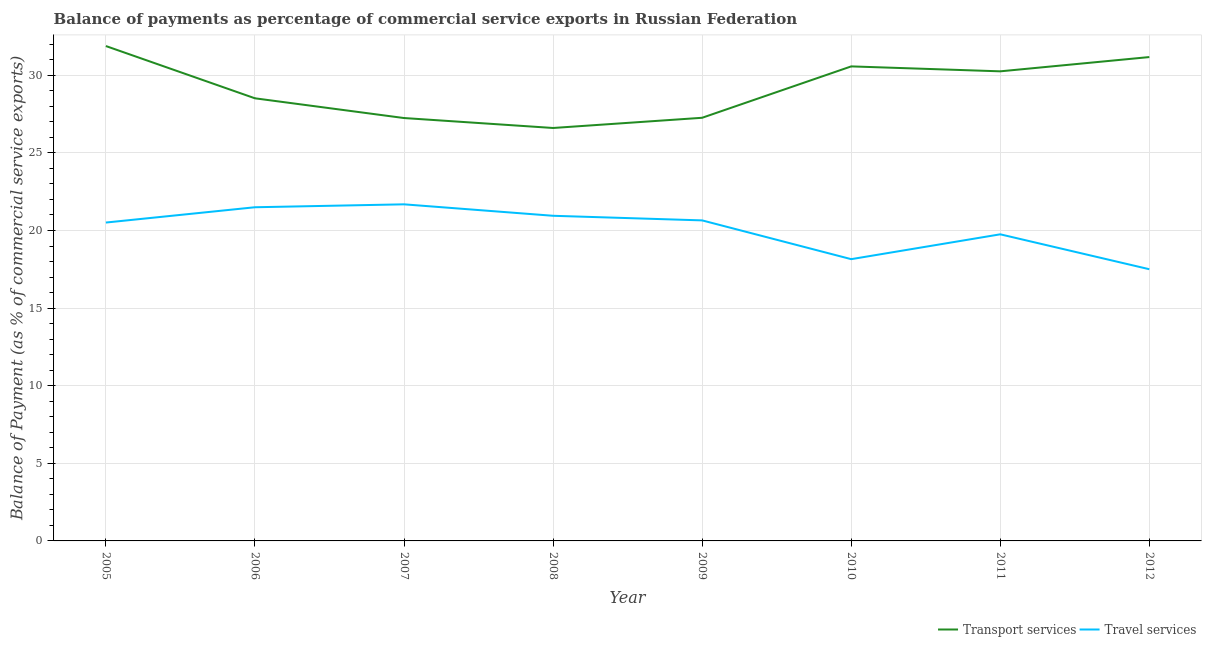Does the line corresponding to balance of payments of transport services intersect with the line corresponding to balance of payments of travel services?
Your response must be concise. No. Is the number of lines equal to the number of legend labels?
Your response must be concise. Yes. What is the balance of payments of transport services in 2012?
Provide a succinct answer. 31.17. Across all years, what is the maximum balance of payments of transport services?
Your answer should be compact. 31.88. Across all years, what is the minimum balance of payments of travel services?
Your response must be concise. 17.5. In which year was the balance of payments of transport services minimum?
Provide a short and direct response. 2008. What is the total balance of payments of travel services in the graph?
Ensure brevity in your answer.  160.7. What is the difference between the balance of payments of transport services in 2010 and that in 2012?
Your answer should be very brief. -0.6. What is the difference between the balance of payments of travel services in 2010 and the balance of payments of transport services in 2005?
Your answer should be very brief. -13.73. What is the average balance of payments of transport services per year?
Your answer should be compact. 29.19. In the year 2009, what is the difference between the balance of payments of transport services and balance of payments of travel services?
Provide a short and direct response. 6.61. What is the ratio of the balance of payments of transport services in 2009 to that in 2012?
Your answer should be compact. 0.87. Is the balance of payments of travel services in 2010 less than that in 2011?
Your response must be concise. Yes. Is the difference between the balance of payments of travel services in 2009 and 2011 greater than the difference between the balance of payments of transport services in 2009 and 2011?
Your answer should be very brief. Yes. What is the difference between the highest and the second highest balance of payments of travel services?
Offer a terse response. 0.19. What is the difference between the highest and the lowest balance of payments of travel services?
Your answer should be very brief. 4.18. In how many years, is the balance of payments of travel services greater than the average balance of payments of travel services taken over all years?
Offer a very short reply. 5. Is the balance of payments of transport services strictly less than the balance of payments of travel services over the years?
Make the answer very short. No. How many lines are there?
Keep it short and to the point. 2. How many years are there in the graph?
Offer a terse response. 8. Are the values on the major ticks of Y-axis written in scientific E-notation?
Give a very brief answer. No. Where does the legend appear in the graph?
Your answer should be very brief. Bottom right. What is the title of the graph?
Your answer should be compact. Balance of payments as percentage of commercial service exports in Russian Federation. Does "Savings" appear as one of the legend labels in the graph?
Your answer should be very brief. No. What is the label or title of the Y-axis?
Provide a short and direct response. Balance of Payment (as % of commercial service exports). What is the Balance of Payment (as % of commercial service exports) of Transport services in 2005?
Give a very brief answer. 31.88. What is the Balance of Payment (as % of commercial service exports) in Travel services in 2005?
Give a very brief answer. 20.51. What is the Balance of Payment (as % of commercial service exports) in Transport services in 2006?
Offer a very short reply. 28.52. What is the Balance of Payment (as % of commercial service exports) of Travel services in 2006?
Make the answer very short. 21.5. What is the Balance of Payment (as % of commercial service exports) in Transport services in 2007?
Your answer should be very brief. 27.25. What is the Balance of Payment (as % of commercial service exports) in Travel services in 2007?
Offer a terse response. 21.69. What is the Balance of Payment (as % of commercial service exports) of Transport services in 2008?
Provide a succinct answer. 26.6. What is the Balance of Payment (as % of commercial service exports) in Travel services in 2008?
Provide a short and direct response. 20.95. What is the Balance of Payment (as % of commercial service exports) in Transport services in 2009?
Ensure brevity in your answer.  27.26. What is the Balance of Payment (as % of commercial service exports) in Travel services in 2009?
Give a very brief answer. 20.65. What is the Balance of Payment (as % of commercial service exports) in Transport services in 2010?
Give a very brief answer. 30.57. What is the Balance of Payment (as % of commercial service exports) in Travel services in 2010?
Make the answer very short. 18.15. What is the Balance of Payment (as % of commercial service exports) in Transport services in 2011?
Give a very brief answer. 30.25. What is the Balance of Payment (as % of commercial service exports) in Travel services in 2011?
Make the answer very short. 19.75. What is the Balance of Payment (as % of commercial service exports) of Transport services in 2012?
Provide a succinct answer. 31.17. What is the Balance of Payment (as % of commercial service exports) of Travel services in 2012?
Make the answer very short. 17.5. Across all years, what is the maximum Balance of Payment (as % of commercial service exports) of Transport services?
Offer a very short reply. 31.88. Across all years, what is the maximum Balance of Payment (as % of commercial service exports) in Travel services?
Your answer should be compact. 21.69. Across all years, what is the minimum Balance of Payment (as % of commercial service exports) in Transport services?
Keep it short and to the point. 26.6. Across all years, what is the minimum Balance of Payment (as % of commercial service exports) in Travel services?
Ensure brevity in your answer.  17.5. What is the total Balance of Payment (as % of commercial service exports) in Transport services in the graph?
Give a very brief answer. 233.51. What is the total Balance of Payment (as % of commercial service exports) in Travel services in the graph?
Give a very brief answer. 160.7. What is the difference between the Balance of Payment (as % of commercial service exports) of Transport services in 2005 and that in 2006?
Make the answer very short. 3.37. What is the difference between the Balance of Payment (as % of commercial service exports) of Travel services in 2005 and that in 2006?
Keep it short and to the point. -0.99. What is the difference between the Balance of Payment (as % of commercial service exports) of Transport services in 2005 and that in 2007?
Provide a succinct answer. 4.64. What is the difference between the Balance of Payment (as % of commercial service exports) in Travel services in 2005 and that in 2007?
Offer a very short reply. -1.17. What is the difference between the Balance of Payment (as % of commercial service exports) of Transport services in 2005 and that in 2008?
Keep it short and to the point. 5.28. What is the difference between the Balance of Payment (as % of commercial service exports) of Travel services in 2005 and that in 2008?
Keep it short and to the point. -0.44. What is the difference between the Balance of Payment (as % of commercial service exports) in Transport services in 2005 and that in 2009?
Your response must be concise. 4.62. What is the difference between the Balance of Payment (as % of commercial service exports) in Travel services in 2005 and that in 2009?
Your answer should be very brief. -0.14. What is the difference between the Balance of Payment (as % of commercial service exports) of Transport services in 2005 and that in 2010?
Offer a very short reply. 1.31. What is the difference between the Balance of Payment (as % of commercial service exports) in Travel services in 2005 and that in 2010?
Make the answer very short. 2.36. What is the difference between the Balance of Payment (as % of commercial service exports) of Transport services in 2005 and that in 2011?
Provide a short and direct response. 1.63. What is the difference between the Balance of Payment (as % of commercial service exports) of Travel services in 2005 and that in 2011?
Offer a very short reply. 0.76. What is the difference between the Balance of Payment (as % of commercial service exports) in Transport services in 2005 and that in 2012?
Offer a terse response. 0.71. What is the difference between the Balance of Payment (as % of commercial service exports) of Travel services in 2005 and that in 2012?
Provide a succinct answer. 3.01. What is the difference between the Balance of Payment (as % of commercial service exports) of Transport services in 2006 and that in 2007?
Provide a succinct answer. 1.27. What is the difference between the Balance of Payment (as % of commercial service exports) of Travel services in 2006 and that in 2007?
Ensure brevity in your answer.  -0.19. What is the difference between the Balance of Payment (as % of commercial service exports) of Transport services in 2006 and that in 2008?
Your response must be concise. 1.91. What is the difference between the Balance of Payment (as % of commercial service exports) of Travel services in 2006 and that in 2008?
Offer a very short reply. 0.55. What is the difference between the Balance of Payment (as % of commercial service exports) in Transport services in 2006 and that in 2009?
Your response must be concise. 1.25. What is the difference between the Balance of Payment (as % of commercial service exports) in Travel services in 2006 and that in 2009?
Your answer should be very brief. 0.85. What is the difference between the Balance of Payment (as % of commercial service exports) in Transport services in 2006 and that in 2010?
Offer a very short reply. -2.06. What is the difference between the Balance of Payment (as % of commercial service exports) in Travel services in 2006 and that in 2010?
Provide a short and direct response. 3.34. What is the difference between the Balance of Payment (as % of commercial service exports) of Transport services in 2006 and that in 2011?
Offer a very short reply. -1.74. What is the difference between the Balance of Payment (as % of commercial service exports) in Travel services in 2006 and that in 2011?
Your answer should be very brief. 1.74. What is the difference between the Balance of Payment (as % of commercial service exports) in Transport services in 2006 and that in 2012?
Offer a very short reply. -2.66. What is the difference between the Balance of Payment (as % of commercial service exports) of Travel services in 2006 and that in 2012?
Make the answer very short. 3.99. What is the difference between the Balance of Payment (as % of commercial service exports) in Transport services in 2007 and that in 2008?
Your answer should be very brief. 0.64. What is the difference between the Balance of Payment (as % of commercial service exports) of Travel services in 2007 and that in 2008?
Your response must be concise. 0.74. What is the difference between the Balance of Payment (as % of commercial service exports) of Transport services in 2007 and that in 2009?
Your response must be concise. -0.02. What is the difference between the Balance of Payment (as % of commercial service exports) in Travel services in 2007 and that in 2009?
Your answer should be very brief. 1.04. What is the difference between the Balance of Payment (as % of commercial service exports) in Transport services in 2007 and that in 2010?
Provide a short and direct response. -3.33. What is the difference between the Balance of Payment (as % of commercial service exports) of Travel services in 2007 and that in 2010?
Ensure brevity in your answer.  3.53. What is the difference between the Balance of Payment (as % of commercial service exports) in Transport services in 2007 and that in 2011?
Give a very brief answer. -3.01. What is the difference between the Balance of Payment (as % of commercial service exports) of Travel services in 2007 and that in 2011?
Your answer should be compact. 1.93. What is the difference between the Balance of Payment (as % of commercial service exports) of Transport services in 2007 and that in 2012?
Ensure brevity in your answer.  -3.93. What is the difference between the Balance of Payment (as % of commercial service exports) in Travel services in 2007 and that in 2012?
Ensure brevity in your answer.  4.18. What is the difference between the Balance of Payment (as % of commercial service exports) of Transport services in 2008 and that in 2009?
Offer a very short reply. -0.66. What is the difference between the Balance of Payment (as % of commercial service exports) in Travel services in 2008 and that in 2009?
Give a very brief answer. 0.3. What is the difference between the Balance of Payment (as % of commercial service exports) of Transport services in 2008 and that in 2010?
Provide a short and direct response. -3.97. What is the difference between the Balance of Payment (as % of commercial service exports) of Travel services in 2008 and that in 2010?
Keep it short and to the point. 2.79. What is the difference between the Balance of Payment (as % of commercial service exports) in Transport services in 2008 and that in 2011?
Keep it short and to the point. -3.65. What is the difference between the Balance of Payment (as % of commercial service exports) in Travel services in 2008 and that in 2011?
Ensure brevity in your answer.  1.19. What is the difference between the Balance of Payment (as % of commercial service exports) in Transport services in 2008 and that in 2012?
Ensure brevity in your answer.  -4.57. What is the difference between the Balance of Payment (as % of commercial service exports) of Travel services in 2008 and that in 2012?
Make the answer very short. 3.44. What is the difference between the Balance of Payment (as % of commercial service exports) of Transport services in 2009 and that in 2010?
Your response must be concise. -3.31. What is the difference between the Balance of Payment (as % of commercial service exports) of Travel services in 2009 and that in 2010?
Make the answer very short. 2.5. What is the difference between the Balance of Payment (as % of commercial service exports) in Transport services in 2009 and that in 2011?
Make the answer very short. -2.99. What is the difference between the Balance of Payment (as % of commercial service exports) in Travel services in 2009 and that in 2011?
Offer a very short reply. 0.9. What is the difference between the Balance of Payment (as % of commercial service exports) of Transport services in 2009 and that in 2012?
Keep it short and to the point. -3.91. What is the difference between the Balance of Payment (as % of commercial service exports) of Travel services in 2009 and that in 2012?
Your answer should be very brief. 3.15. What is the difference between the Balance of Payment (as % of commercial service exports) in Transport services in 2010 and that in 2011?
Offer a terse response. 0.32. What is the difference between the Balance of Payment (as % of commercial service exports) of Travel services in 2010 and that in 2011?
Make the answer very short. -1.6. What is the difference between the Balance of Payment (as % of commercial service exports) of Transport services in 2010 and that in 2012?
Keep it short and to the point. -0.6. What is the difference between the Balance of Payment (as % of commercial service exports) of Travel services in 2010 and that in 2012?
Your answer should be compact. 0.65. What is the difference between the Balance of Payment (as % of commercial service exports) in Transport services in 2011 and that in 2012?
Your answer should be very brief. -0.92. What is the difference between the Balance of Payment (as % of commercial service exports) in Travel services in 2011 and that in 2012?
Provide a short and direct response. 2.25. What is the difference between the Balance of Payment (as % of commercial service exports) of Transport services in 2005 and the Balance of Payment (as % of commercial service exports) of Travel services in 2006?
Give a very brief answer. 10.39. What is the difference between the Balance of Payment (as % of commercial service exports) in Transport services in 2005 and the Balance of Payment (as % of commercial service exports) in Travel services in 2007?
Offer a very short reply. 10.2. What is the difference between the Balance of Payment (as % of commercial service exports) in Transport services in 2005 and the Balance of Payment (as % of commercial service exports) in Travel services in 2008?
Your response must be concise. 10.94. What is the difference between the Balance of Payment (as % of commercial service exports) in Transport services in 2005 and the Balance of Payment (as % of commercial service exports) in Travel services in 2009?
Keep it short and to the point. 11.23. What is the difference between the Balance of Payment (as % of commercial service exports) in Transport services in 2005 and the Balance of Payment (as % of commercial service exports) in Travel services in 2010?
Give a very brief answer. 13.73. What is the difference between the Balance of Payment (as % of commercial service exports) in Transport services in 2005 and the Balance of Payment (as % of commercial service exports) in Travel services in 2011?
Offer a very short reply. 12.13. What is the difference between the Balance of Payment (as % of commercial service exports) of Transport services in 2005 and the Balance of Payment (as % of commercial service exports) of Travel services in 2012?
Provide a succinct answer. 14.38. What is the difference between the Balance of Payment (as % of commercial service exports) in Transport services in 2006 and the Balance of Payment (as % of commercial service exports) in Travel services in 2007?
Offer a terse response. 6.83. What is the difference between the Balance of Payment (as % of commercial service exports) in Transport services in 2006 and the Balance of Payment (as % of commercial service exports) in Travel services in 2008?
Offer a very short reply. 7.57. What is the difference between the Balance of Payment (as % of commercial service exports) of Transport services in 2006 and the Balance of Payment (as % of commercial service exports) of Travel services in 2009?
Your answer should be very brief. 7.87. What is the difference between the Balance of Payment (as % of commercial service exports) in Transport services in 2006 and the Balance of Payment (as % of commercial service exports) in Travel services in 2010?
Make the answer very short. 10.36. What is the difference between the Balance of Payment (as % of commercial service exports) in Transport services in 2006 and the Balance of Payment (as % of commercial service exports) in Travel services in 2011?
Offer a terse response. 8.76. What is the difference between the Balance of Payment (as % of commercial service exports) of Transport services in 2006 and the Balance of Payment (as % of commercial service exports) of Travel services in 2012?
Keep it short and to the point. 11.01. What is the difference between the Balance of Payment (as % of commercial service exports) of Transport services in 2007 and the Balance of Payment (as % of commercial service exports) of Travel services in 2008?
Make the answer very short. 6.3. What is the difference between the Balance of Payment (as % of commercial service exports) of Transport services in 2007 and the Balance of Payment (as % of commercial service exports) of Travel services in 2009?
Keep it short and to the point. 6.59. What is the difference between the Balance of Payment (as % of commercial service exports) of Transport services in 2007 and the Balance of Payment (as % of commercial service exports) of Travel services in 2010?
Keep it short and to the point. 9.09. What is the difference between the Balance of Payment (as % of commercial service exports) of Transport services in 2007 and the Balance of Payment (as % of commercial service exports) of Travel services in 2011?
Make the answer very short. 7.49. What is the difference between the Balance of Payment (as % of commercial service exports) of Transport services in 2007 and the Balance of Payment (as % of commercial service exports) of Travel services in 2012?
Your answer should be compact. 9.74. What is the difference between the Balance of Payment (as % of commercial service exports) of Transport services in 2008 and the Balance of Payment (as % of commercial service exports) of Travel services in 2009?
Give a very brief answer. 5.95. What is the difference between the Balance of Payment (as % of commercial service exports) of Transport services in 2008 and the Balance of Payment (as % of commercial service exports) of Travel services in 2010?
Keep it short and to the point. 8.45. What is the difference between the Balance of Payment (as % of commercial service exports) in Transport services in 2008 and the Balance of Payment (as % of commercial service exports) in Travel services in 2011?
Your response must be concise. 6.85. What is the difference between the Balance of Payment (as % of commercial service exports) of Transport services in 2009 and the Balance of Payment (as % of commercial service exports) of Travel services in 2010?
Provide a succinct answer. 9.11. What is the difference between the Balance of Payment (as % of commercial service exports) of Transport services in 2009 and the Balance of Payment (as % of commercial service exports) of Travel services in 2011?
Provide a succinct answer. 7.51. What is the difference between the Balance of Payment (as % of commercial service exports) in Transport services in 2009 and the Balance of Payment (as % of commercial service exports) in Travel services in 2012?
Provide a short and direct response. 9.76. What is the difference between the Balance of Payment (as % of commercial service exports) in Transport services in 2010 and the Balance of Payment (as % of commercial service exports) in Travel services in 2011?
Keep it short and to the point. 10.82. What is the difference between the Balance of Payment (as % of commercial service exports) of Transport services in 2010 and the Balance of Payment (as % of commercial service exports) of Travel services in 2012?
Your answer should be compact. 13.07. What is the difference between the Balance of Payment (as % of commercial service exports) in Transport services in 2011 and the Balance of Payment (as % of commercial service exports) in Travel services in 2012?
Your response must be concise. 12.75. What is the average Balance of Payment (as % of commercial service exports) in Transport services per year?
Offer a terse response. 29.19. What is the average Balance of Payment (as % of commercial service exports) of Travel services per year?
Provide a short and direct response. 20.09. In the year 2005, what is the difference between the Balance of Payment (as % of commercial service exports) of Transport services and Balance of Payment (as % of commercial service exports) of Travel services?
Offer a very short reply. 11.37. In the year 2006, what is the difference between the Balance of Payment (as % of commercial service exports) of Transport services and Balance of Payment (as % of commercial service exports) of Travel services?
Offer a very short reply. 7.02. In the year 2007, what is the difference between the Balance of Payment (as % of commercial service exports) of Transport services and Balance of Payment (as % of commercial service exports) of Travel services?
Give a very brief answer. 5.56. In the year 2008, what is the difference between the Balance of Payment (as % of commercial service exports) in Transport services and Balance of Payment (as % of commercial service exports) in Travel services?
Give a very brief answer. 5.66. In the year 2009, what is the difference between the Balance of Payment (as % of commercial service exports) of Transport services and Balance of Payment (as % of commercial service exports) of Travel services?
Your response must be concise. 6.61. In the year 2010, what is the difference between the Balance of Payment (as % of commercial service exports) in Transport services and Balance of Payment (as % of commercial service exports) in Travel services?
Provide a succinct answer. 12.42. In the year 2011, what is the difference between the Balance of Payment (as % of commercial service exports) of Transport services and Balance of Payment (as % of commercial service exports) of Travel services?
Offer a terse response. 10.5. In the year 2012, what is the difference between the Balance of Payment (as % of commercial service exports) of Transport services and Balance of Payment (as % of commercial service exports) of Travel services?
Keep it short and to the point. 13.67. What is the ratio of the Balance of Payment (as % of commercial service exports) in Transport services in 2005 to that in 2006?
Provide a succinct answer. 1.12. What is the ratio of the Balance of Payment (as % of commercial service exports) in Travel services in 2005 to that in 2006?
Your answer should be compact. 0.95. What is the ratio of the Balance of Payment (as % of commercial service exports) of Transport services in 2005 to that in 2007?
Offer a terse response. 1.17. What is the ratio of the Balance of Payment (as % of commercial service exports) in Travel services in 2005 to that in 2007?
Your answer should be very brief. 0.95. What is the ratio of the Balance of Payment (as % of commercial service exports) of Transport services in 2005 to that in 2008?
Provide a short and direct response. 1.2. What is the ratio of the Balance of Payment (as % of commercial service exports) in Travel services in 2005 to that in 2008?
Ensure brevity in your answer.  0.98. What is the ratio of the Balance of Payment (as % of commercial service exports) of Transport services in 2005 to that in 2009?
Make the answer very short. 1.17. What is the ratio of the Balance of Payment (as % of commercial service exports) in Transport services in 2005 to that in 2010?
Offer a terse response. 1.04. What is the ratio of the Balance of Payment (as % of commercial service exports) of Travel services in 2005 to that in 2010?
Ensure brevity in your answer.  1.13. What is the ratio of the Balance of Payment (as % of commercial service exports) in Transport services in 2005 to that in 2011?
Provide a succinct answer. 1.05. What is the ratio of the Balance of Payment (as % of commercial service exports) in Travel services in 2005 to that in 2011?
Give a very brief answer. 1.04. What is the ratio of the Balance of Payment (as % of commercial service exports) of Transport services in 2005 to that in 2012?
Provide a short and direct response. 1.02. What is the ratio of the Balance of Payment (as % of commercial service exports) in Travel services in 2005 to that in 2012?
Provide a short and direct response. 1.17. What is the ratio of the Balance of Payment (as % of commercial service exports) in Transport services in 2006 to that in 2007?
Provide a short and direct response. 1.05. What is the ratio of the Balance of Payment (as % of commercial service exports) of Travel services in 2006 to that in 2007?
Your answer should be compact. 0.99. What is the ratio of the Balance of Payment (as % of commercial service exports) of Transport services in 2006 to that in 2008?
Your answer should be compact. 1.07. What is the ratio of the Balance of Payment (as % of commercial service exports) in Travel services in 2006 to that in 2008?
Your answer should be compact. 1.03. What is the ratio of the Balance of Payment (as % of commercial service exports) in Transport services in 2006 to that in 2009?
Your response must be concise. 1.05. What is the ratio of the Balance of Payment (as % of commercial service exports) in Travel services in 2006 to that in 2009?
Your response must be concise. 1.04. What is the ratio of the Balance of Payment (as % of commercial service exports) of Transport services in 2006 to that in 2010?
Offer a terse response. 0.93. What is the ratio of the Balance of Payment (as % of commercial service exports) in Travel services in 2006 to that in 2010?
Make the answer very short. 1.18. What is the ratio of the Balance of Payment (as % of commercial service exports) in Transport services in 2006 to that in 2011?
Keep it short and to the point. 0.94. What is the ratio of the Balance of Payment (as % of commercial service exports) of Travel services in 2006 to that in 2011?
Your response must be concise. 1.09. What is the ratio of the Balance of Payment (as % of commercial service exports) of Transport services in 2006 to that in 2012?
Offer a very short reply. 0.91. What is the ratio of the Balance of Payment (as % of commercial service exports) in Travel services in 2006 to that in 2012?
Your response must be concise. 1.23. What is the ratio of the Balance of Payment (as % of commercial service exports) in Transport services in 2007 to that in 2008?
Offer a very short reply. 1.02. What is the ratio of the Balance of Payment (as % of commercial service exports) in Travel services in 2007 to that in 2008?
Provide a succinct answer. 1.04. What is the ratio of the Balance of Payment (as % of commercial service exports) in Travel services in 2007 to that in 2009?
Offer a very short reply. 1.05. What is the ratio of the Balance of Payment (as % of commercial service exports) in Transport services in 2007 to that in 2010?
Provide a succinct answer. 0.89. What is the ratio of the Balance of Payment (as % of commercial service exports) in Travel services in 2007 to that in 2010?
Keep it short and to the point. 1.19. What is the ratio of the Balance of Payment (as % of commercial service exports) of Transport services in 2007 to that in 2011?
Your response must be concise. 0.9. What is the ratio of the Balance of Payment (as % of commercial service exports) of Travel services in 2007 to that in 2011?
Your answer should be compact. 1.1. What is the ratio of the Balance of Payment (as % of commercial service exports) of Transport services in 2007 to that in 2012?
Provide a short and direct response. 0.87. What is the ratio of the Balance of Payment (as % of commercial service exports) in Travel services in 2007 to that in 2012?
Provide a short and direct response. 1.24. What is the ratio of the Balance of Payment (as % of commercial service exports) in Transport services in 2008 to that in 2009?
Your response must be concise. 0.98. What is the ratio of the Balance of Payment (as % of commercial service exports) in Travel services in 2008 to that in 2009?
Offer a terse response. 1.01. What is the ratio of the Balance of Payment (as % of commercial service exports) in Transport services in 2008 to that in 2010?
Give a very brief answer. 0.87. What is the ratio of the Balance of Payment (as % of commercial service exports) of Travel services in 2008 to that in 2010?
Provide a succinct answer. 1.15. What is the ratio of the Balance of Payment (as % of commercial service exports) of Transport services in 2008 to that in 2011?
Your response must be concise. 0.88. What is the ratio of the Balance of Payment (as % of commercial service exports) of Travel services in 2008 to that in 2011?
Your response must be concise. 1.06. What is the ratio of the Balance of Payment (as % of commercial service exports) of Transport services in 2008 to that in 2012?
Offer a very short reply. 0.85. What is the ratio of the Balance of Payment (as % of commercial service exports) in Travel services in 2008 to that in 2012?
Your response must be concise. 1.2. What is the ratio of the Balance of Payment (as % of commercial service exports) of Transport services in 2009 to that in 2010?
Offer a very short reply. 0.89. What is the ratio of the Balance of Payment (as % of commercial service exports) in Travel services in 2009 to that in 2010?
Give a very brief answer. 1.14. What is the ratio of the Balance of Payment (as % of commercial service exports) in Transport services in 2009 to that in 2011?
Offer a terse response. 0.9. What is the ratio of the Balance of Payment (as % of commercial service exports) in Travel services in 2009 to that in 2011?
Offer a terse response. 1.05. What is the ratio of the Balance of Payment (as % of commercial service exports) in Transport services in 2009 to that in 2012?
Your answer should be compact. 0.87. What is the ratio of the Balance of Payment (as % of commercial service exports) of Travel services in 2009 to that in 2012?
Your answer should be compact. 1.18. What is the ratio of the Balance of Payment (as % of commercial service exports) in Transport services in 2010 to that in 2011?
Ensure brevity in your answer.  1.01. What is the ratio of the Balance of Payment (as % of commercial service exports) in Travel services in 2010 to that in 2011?
Your answer should be very brief. 0.92. What is the ratio of the Balance of Payment (as % of commercial service exports) of Transport services in 2010 to that in 2012?
Offer a very short reply. 0.98. What is the ratio of the Balance of Payment (as % of commercial service exports) in Travel services in 2010 to that in 2012?
Give a very brief answer. 1.04. What is the ratio of the Balance of Payment (as % of commercial service exports) in Transport services in 2011 to that in 2012?
Your response must be concise. 0.97. What is the ratio of the Balance of Payment (as % of commercial service exports) in Travel services in 2011 to that in 2012?
Provide a succinct answer. 1.13. What is the difference between the highest and the second highest Balance of Payment (as % of commercial service exports) of Transport services?
Your answer should be very brief. 0.71. What is the difference between the highest and the second highest Balance of Payment (as % of commercial service exports) in Travel services?
Provide a short and direct response. 0.19. What is the difference between the highest and the lowest Balance of Payment (as % of commercial service exports) in Transport services?
Provide a succinct answer. 5.28. What is the difference between the highest and the lowest Balance of Payment (as % of commercial service exports) in Travel services?
Keep it short and to the point. 4.18. 